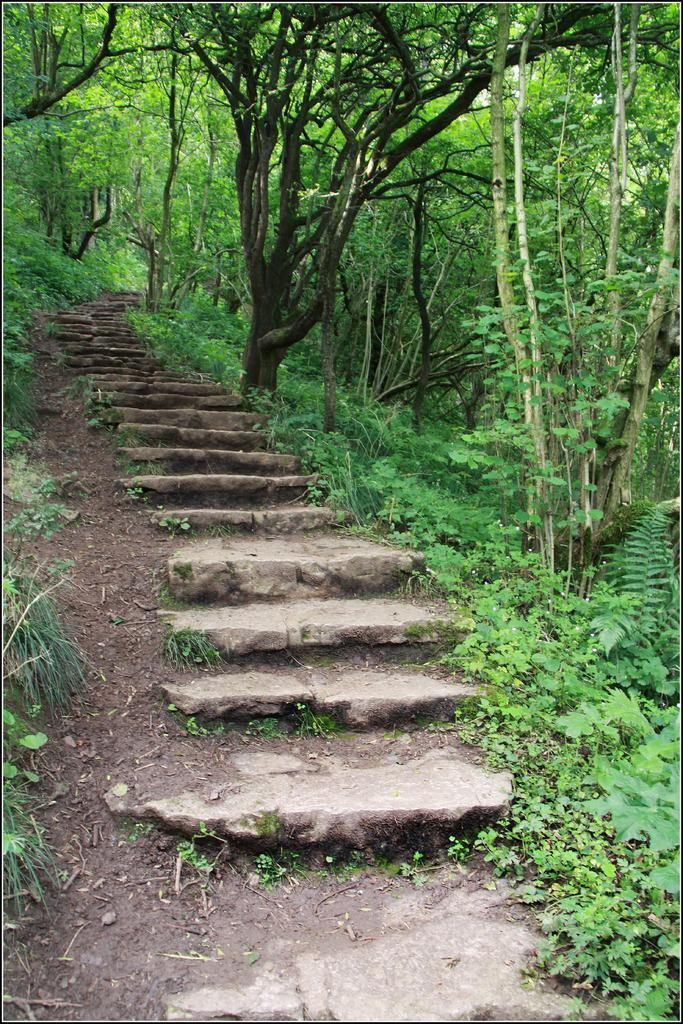Describe this image in one or two sentences. This is the picture of a place where we have a staircase with the marbles and around there are some trees and plants. 